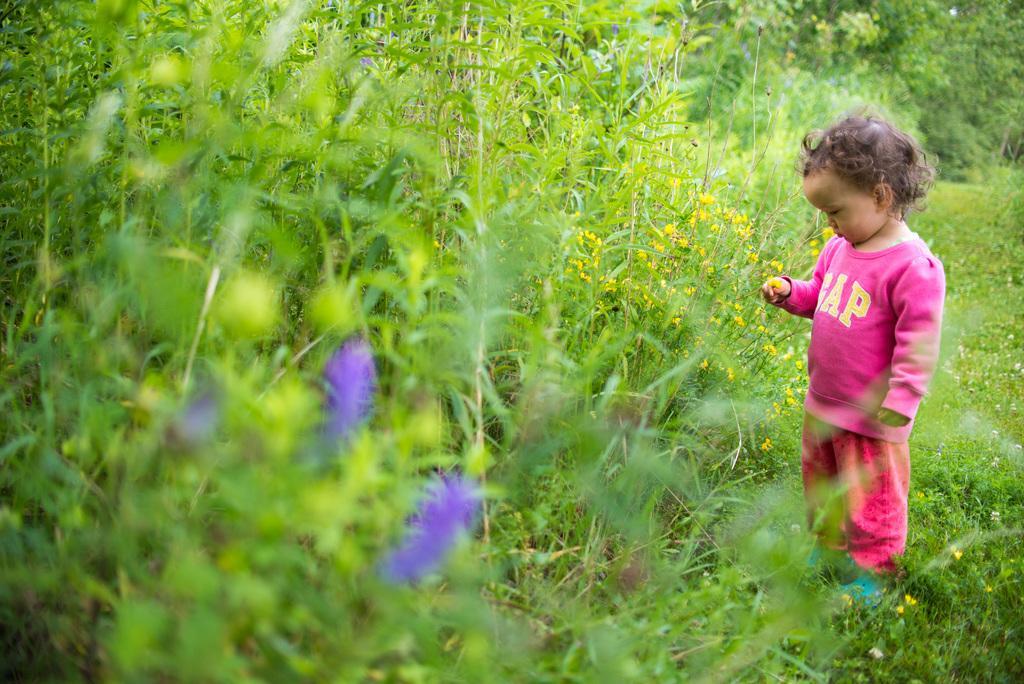Please provide a concise description of this image. In this image we can see a kid standing on the ground, there are few plants with flowers and trees in the background. 